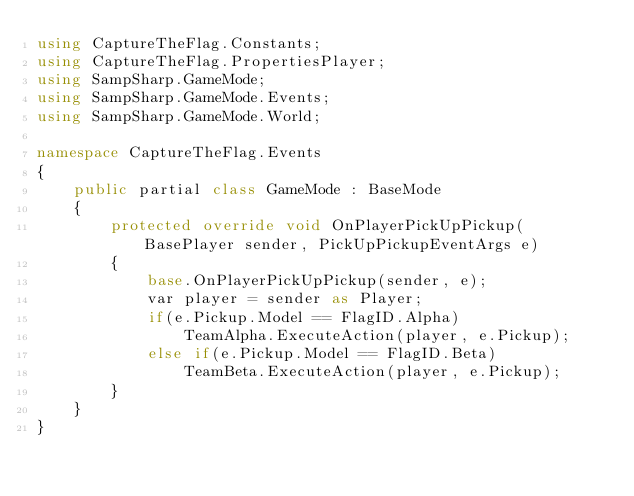Convert code to text. <code><loc_0><loc_0><loc_500><loc_500><_C#_>using CaptureTheFlag.Constants;
using CaptureTheFlag.PropertiesPlayer;
using SampSharp.GameMode;
using SampSharp.GameMode.Events;
using SampSharp.GameMode.World;

namespace CaptureTheFlag.Events
{
    public partial class GameMode : BaseMode
    {
        protected override void OnPlayerPickUpPickup(BasePlayer sender, PickUpPickupEventArgs e)
        {
            base.OnPlayerPickUpPickup(sender, e);
            var player = sender as Player;
            if(e.Pickup.Model == FlagID.Alpha)
                TeamAlpha.ExecuteAction(player, e.Pickup);
            else if(e.Pickup.Model == FlagID.Beta)
                TeamBeta.ExecuteAction(player, e.Pickup);
        }
    }
}</code> 